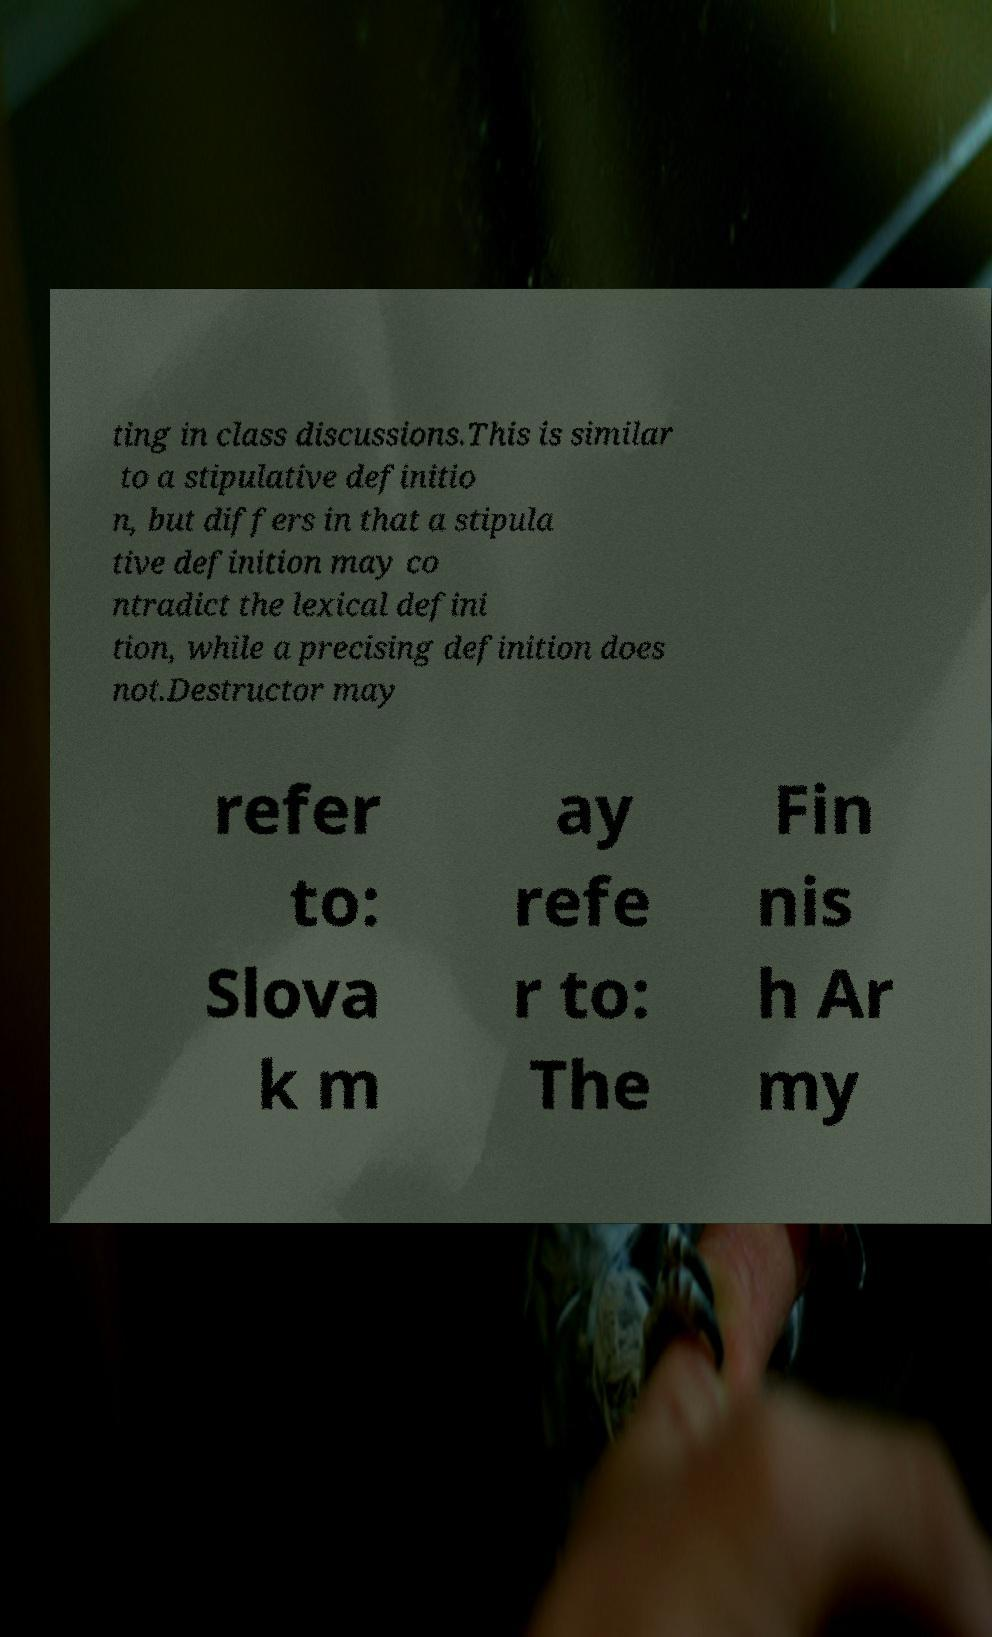I need the written content from this picture converted into text. Can you do that? ting in class discussions.This is similar to a stipulative definitio n, but differs in that a stipula tive definition may co ntradict the lexical defini tion, while a precising definition does not.Destructor may refer to: Slova k m ay refe r to: The Fin nis h Ar my 